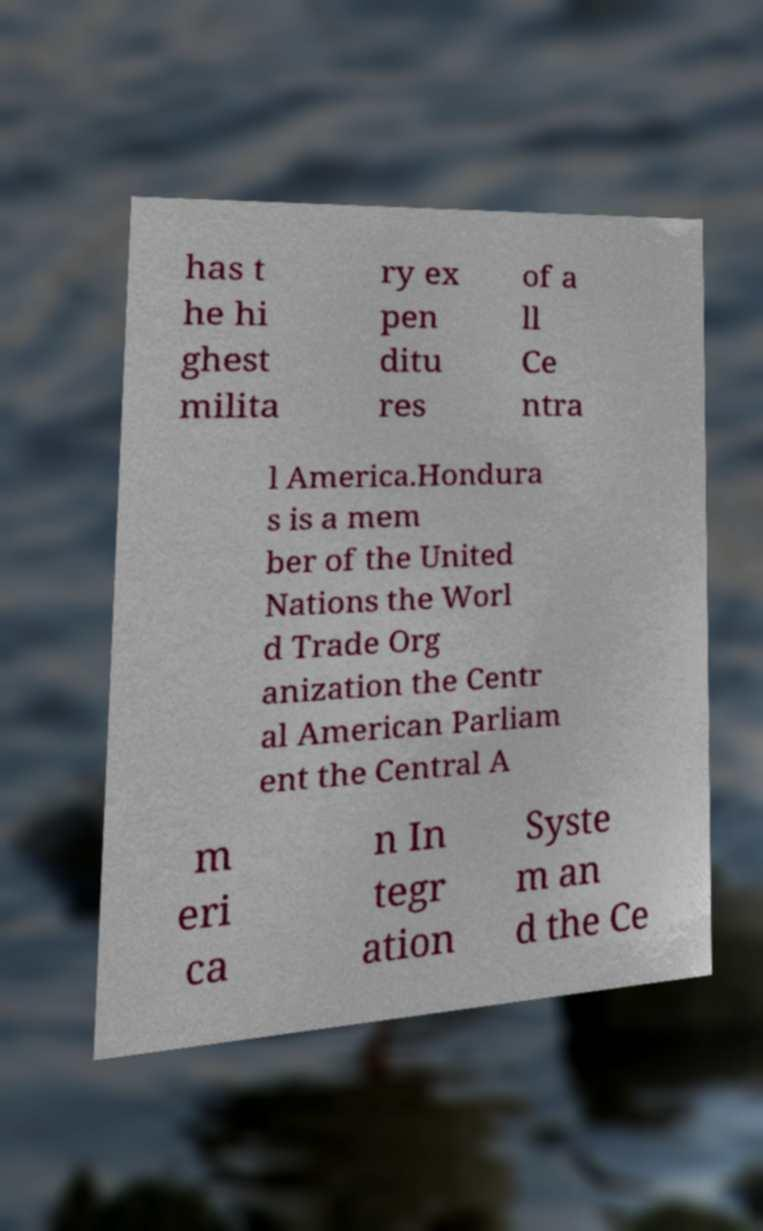Can you accurately transcribe the text from the provided image for me? has t he hi ghest milita ry ex pen ditu res of a ll Ce ntra l America.Hondura s is a mem ber of the United Nations the Worl d Trade Org anization the Centr al American Parliam ent the Central A m eri ca n In tegr ation Syste m an d the Ce 